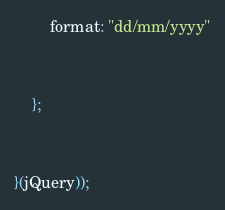Convert code to text. <code><loc_0><loc_0><loc_500><loc_500><_JavaScript_>		format: "dd/mm/yyyy"
	};
}(jQuery));
</code> 